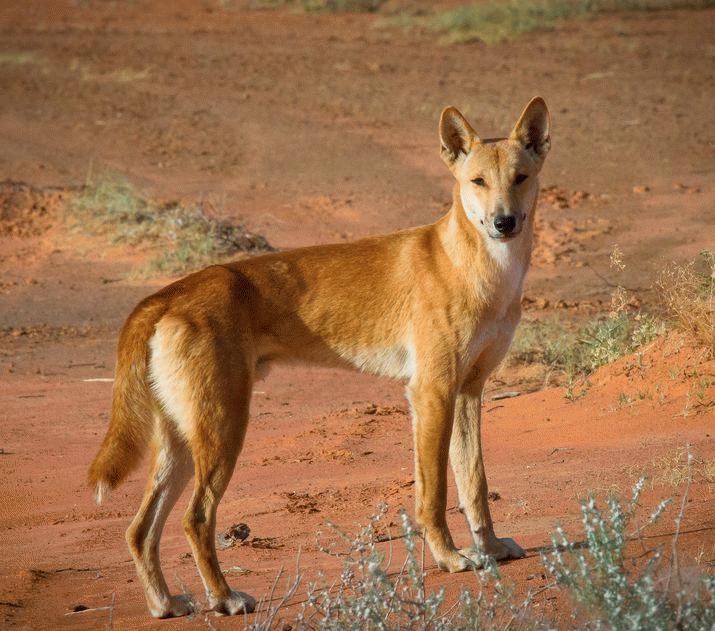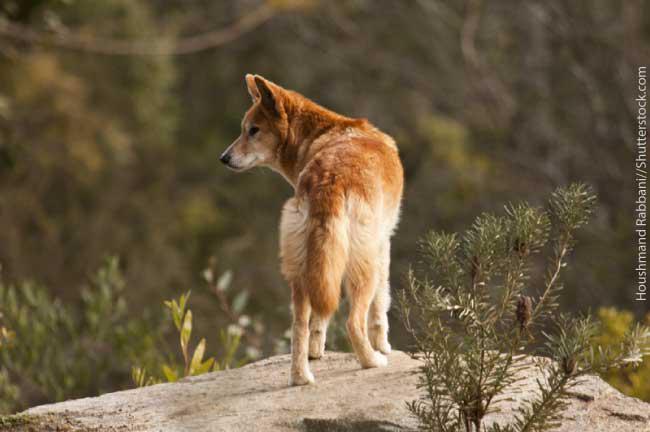The first image is the image on the left, the second image is the image on the right. Given the left and right images, does the statement "At least one animal is lying on the ground in the image on the right." hold true? Answer yes or no. No. 